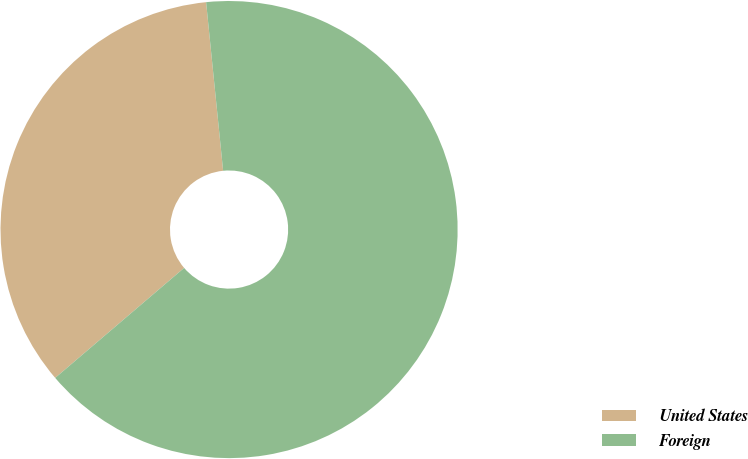Convert chart. <chart><loc_0><loc_0><loc_500><loc_500><pie_chart><fcel>United States<fcel>Foreign<nl><fcel>34.64%<fcel>65.36%<nl></chart> 